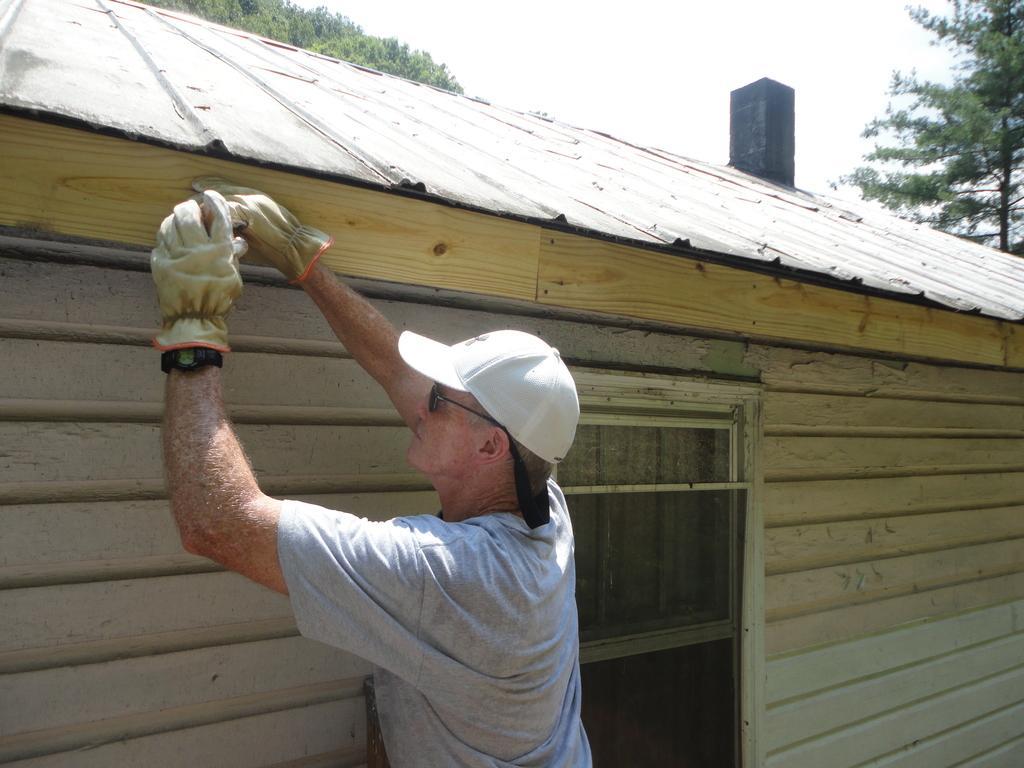In one or two sentences, can you explain what this image depicts? In this image there is a person standing near a house, in the background there are trees. 